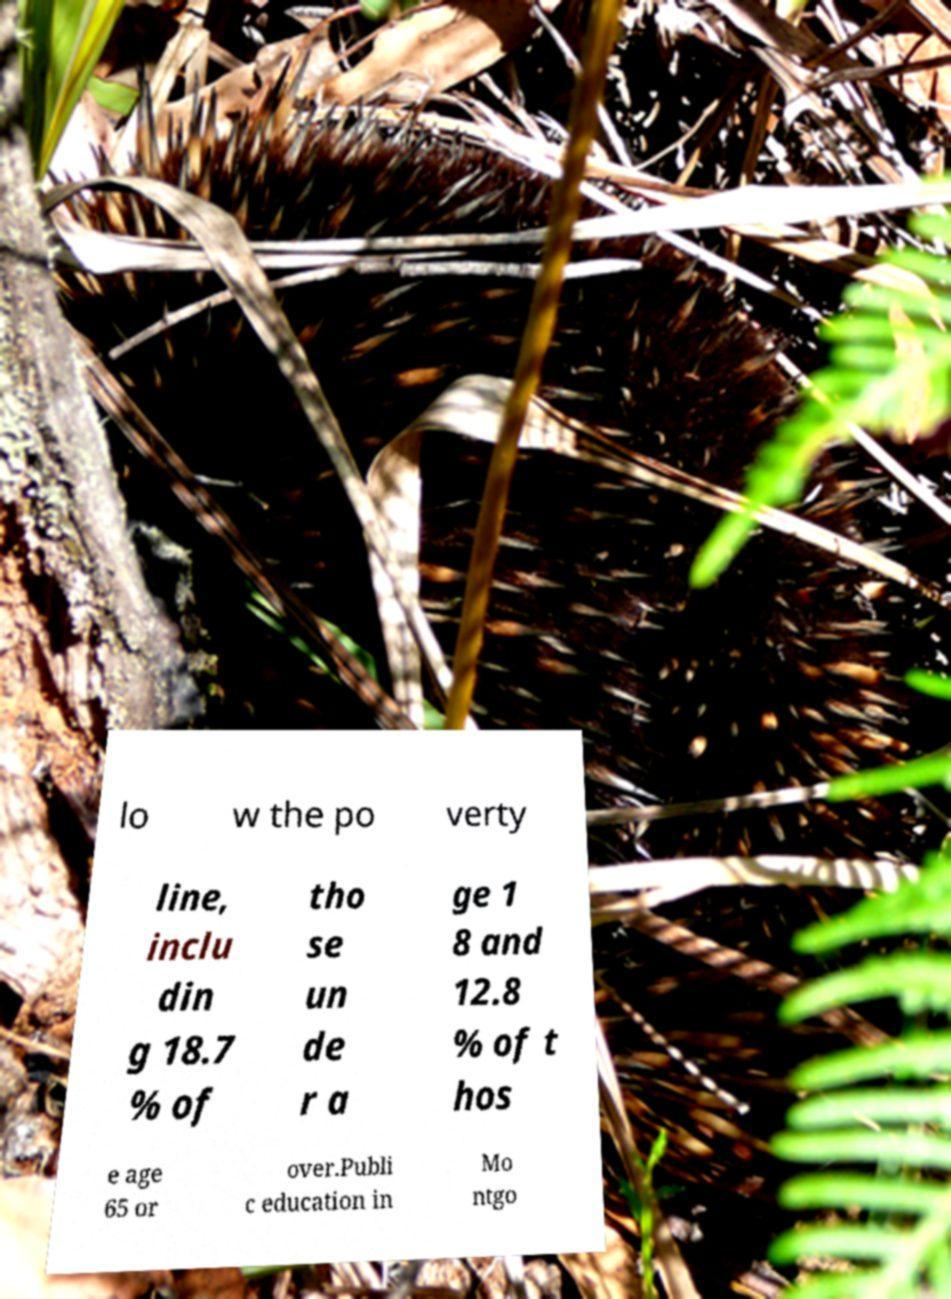Please read and relay the text visible in this image. What does it say? lo w the po verty line, inclu din g 18.7 % of tho se un de r a ge 1 8 and 12.8 % of t hos e age 65 or over.Publi c education in Mo ntgo 